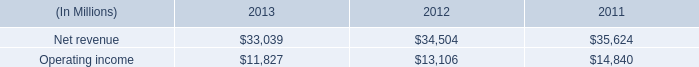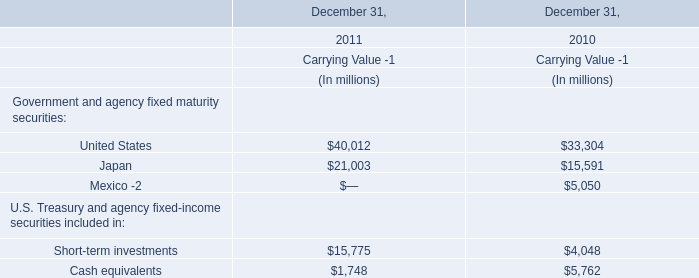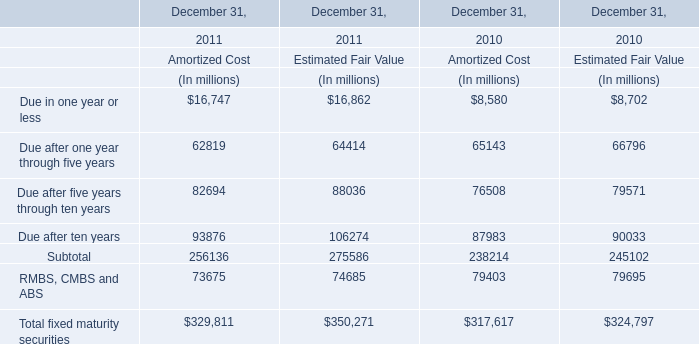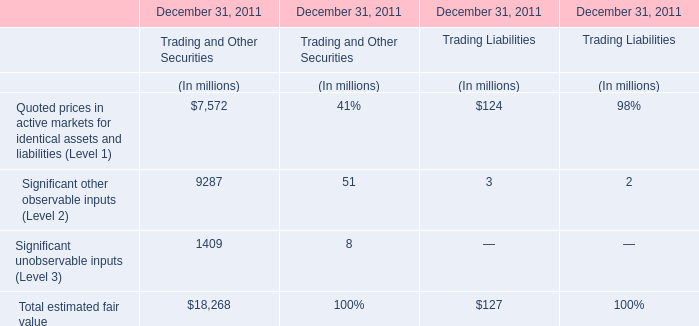What do all Estimated Fair Value sum up without those Estimated Fair Value smaller than 100000, in 2011? (in million) 
Computations: (106274 + 275586)
Answer: 381860.0. 